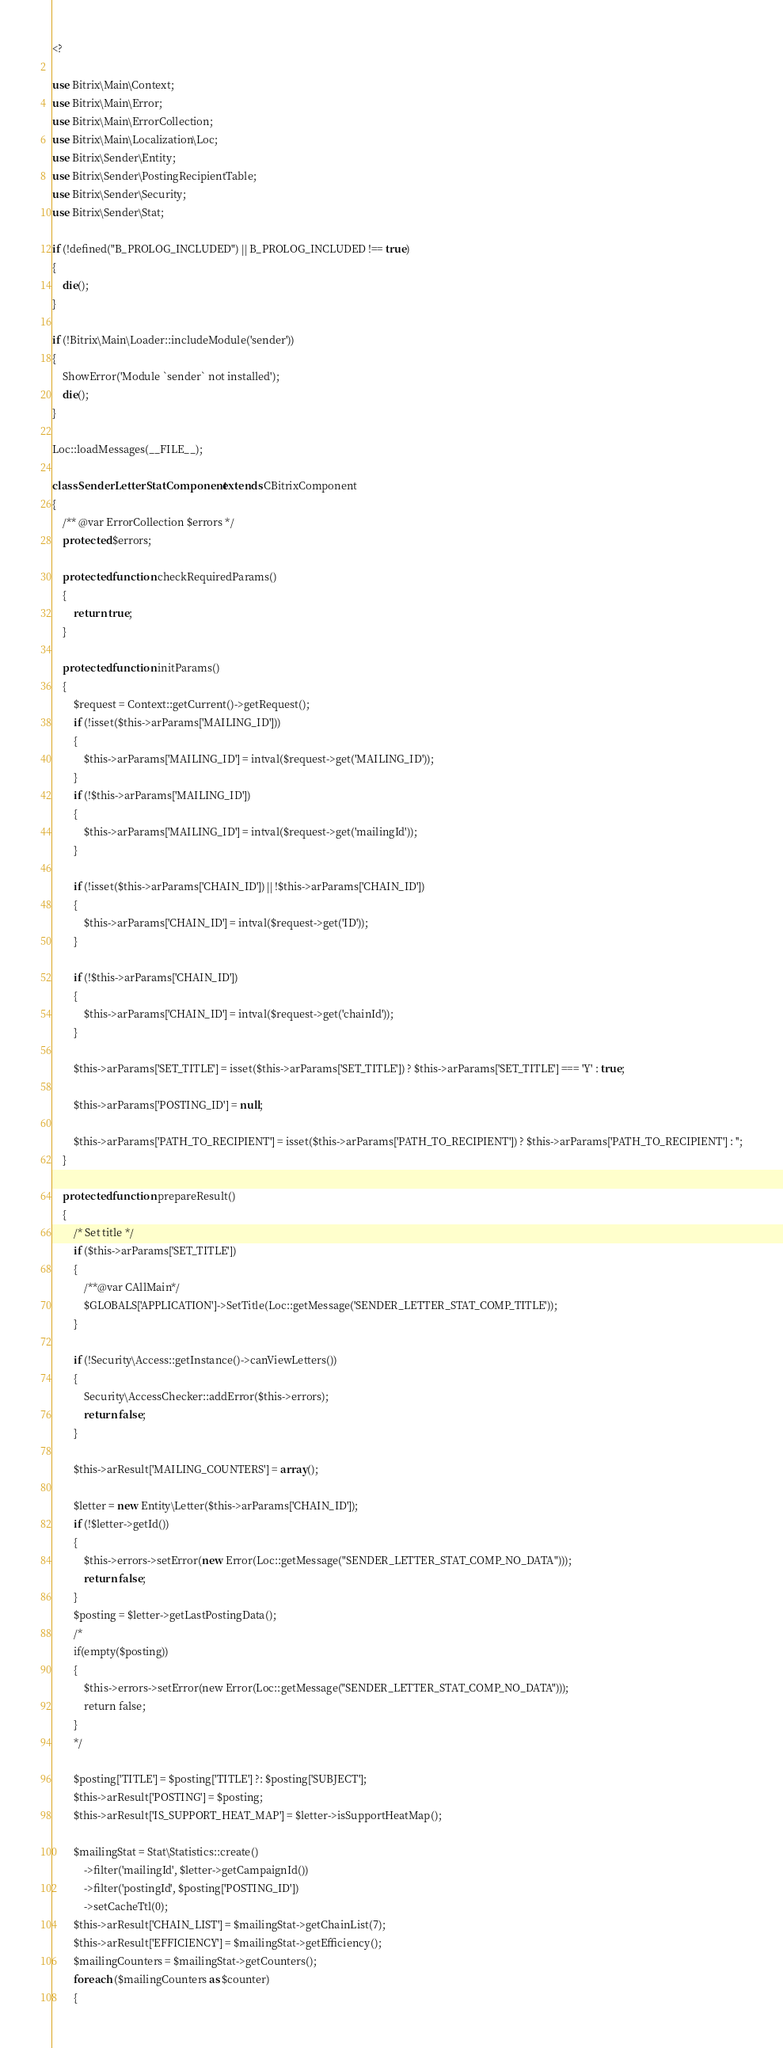Convert code to text. <code><loc_0><loc_0><loc_500><loc_500><_PHP_><?

use Bitrix\Main\Context;
use Bitrix\Main\Error;
use Bitrix\Main\ErrorCollection;
use Bitrix\Main\Localization\Loc;
use Bitrix\Sender\Entity;
use Bitrix\Sender\PostingRecipientTable;
use Bitrix\Sender\Security;
use Bitrix\Sender\Stat;

if (!defined("B_PROLOG_INCLUDED") || B_PROLOG_INCLUDED !== true)
{
	die();
}

if (!Bitrix\Main\Loader::includeModule('sender'))
{
	ShowError('Module `sender` not installed');
	die();
}

Loc::loadMessages(__FILE__);

class SenderLetterStatComponent extends CBitrixComponent
{
	/** @var ErrorCollection $errors */
	protected $errors;

	protected function checkRequiredParams()
	{
		return true;
	}

	protected function initParams()
	{
		$request = Context::getCurrent()->getRequest();
		if (!isset($this->arParams['MAILING_ID']))
		{
			$this->arParams['MAILING_ID'] = intval($request->get('MAILING_ID'));
		}
		if (!$this->arParams['MAILING_ID'])
		{
			$this->arParams['MAILING_ID'] = intval($request->get('mailingId'));
		}

		if (!isset($this->arParams['CHAIN_ID']) || !$this->arParams['CHAIN_ID'])
		{
			$this->arParams['CHAIN_ID'] = intval($request->get('ID'));
		}

		if (!$this->arParams['CHAIN_ID'])
		{
			$this->arParams['CHAIN_ID'] = intval($request->get('chainId'));
		}

		$this->arParams['SET_TITLE'] = isset($this->arParams['SET_TITLE']) ? $this->arParams['SET_TITLE'] === 'Y' : true;

		$this->arParams['POSTING_ID'] = null;

		$this->arParams['PATH_TO_RECIPIENT'] = isset($this->arParams['PATH_TO_RECIPIENT']) ? $this->arParams['PATH_TO_RECIPIENT'] : '';
	}

	protected function prepareResult()
	{
		/* Set title */
		if ($this->arParams['SET_TITLE'])
		{
			/**@var CAllMain*/
			$GLOBALS['APPLICATION']->SetTitle(Loc::getMessage('SENDER_LETTER_STAT_COMP_TITLE'));
		}

		if (!Security\Access::getInstance()->canViewLetters())
		{
			Security\AccessChecker::addError($this->errors);
			return false;
		}

		$this->arResult['MAILING_COUNTERS'] = array();

		$letter = new Entity\Letter($this->arParams['CHAIN_ID']);
		if (!$letter->getId())
		{
			$this->errors->setError(new Error(Loc::getMessage("SENDER_LETTER_STAT_COMP_NO_DATA")));
			return false;
		}
		$posting = $letter->getLastPostingData();
		/*
		if(empty($posting))
		{
			$this->errors->setError(new Error(Loc::getMessage("SENDER_LETTER_STAT_COMP_NO_DATA")));
			return false;
		}
		*/

		$posting['TITLE'] = $posting['TITLE'] ?: $posting['SUBJECT'];
		$this->arResult['POSTING'] = $posting;
		$this->arResult['IS_SUPPORT_HEAT_MAP'] = $letter->isSupportHeatMap();

		$mailingStat = Stat\Statistics::create()
			->filter('mailingId', $letter->getCampaignId())
			->filter('postingId', $posting['POSTING_ID'])
			->setCacheTtl(0);
		$this->arResult['CHAIN_LIST'] = $mailingStat->getChainList(7);
		$this->arResult['EFFICIENCY'] = $mailingStat->getEfficiency();
		$mailingCounters = $mailingStat->getCounters();
		foreach ($mailingCounters as $counter)
		{</code> 